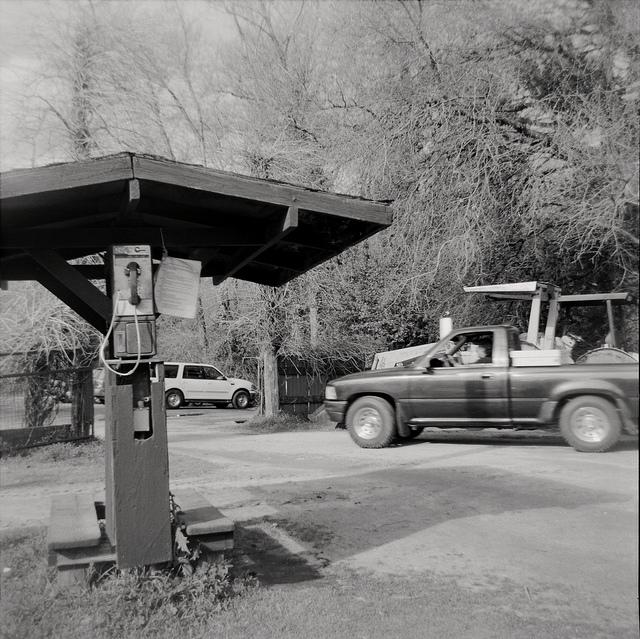The item under the roof can best be described as what?

Choices:
A) cutting edge
B) outdated
C) underwater
D) bovine outdated 